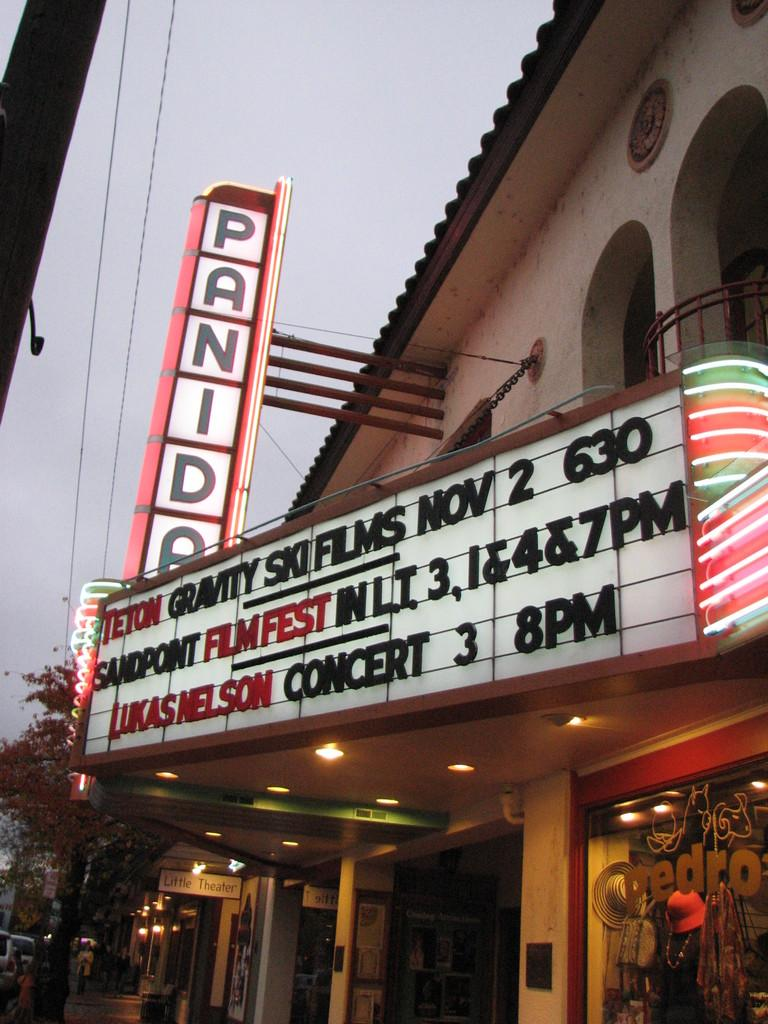What type of structure is present in the image? There is a building in the image. What is the color of the building? The building is cream in color. What objects can be seen in the image besides the building? There are boards and lights visible in the image. What can be seen in the background of the image? There are trees, lights, and the sky visible in the background of the image. How many hats are visible on the building in the image? There are no hats present on the building in the image. What type of toys can be seen in the background of the image? There are no toys present in the image; only trees, lights, and the sky are visible in the background. 